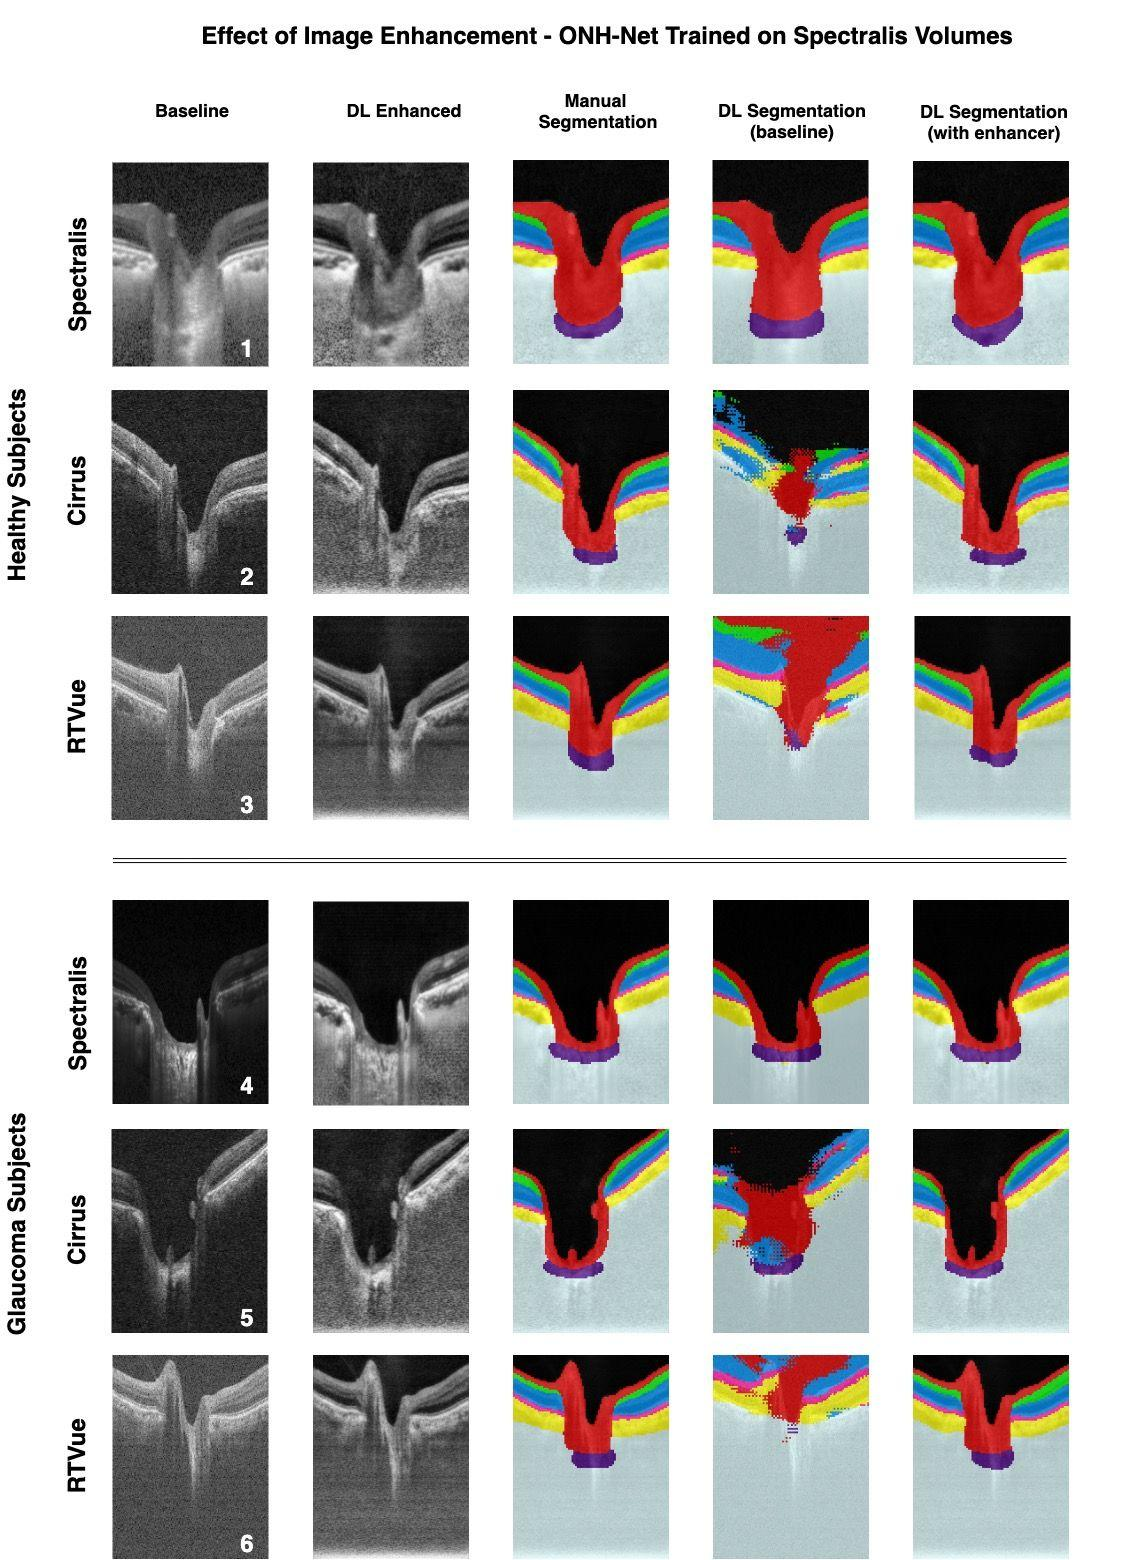In the context of the provided image, why might deep learning-enhanced segmentation be preferred over manual segmentation? Deep learning-enhanced segmentation may be preferred over manual segmentation for several reasons. Firstly, manual segmentation, while accurate, is labor-intensive and time-consuming, which limits its practicality in high-volume clinical settings. In contrast, DL-enhanced segmentation can be automated, greatly reducing analysis time. Secondly, DL algorithms can maintain consistency across numerous images, eliminating the variability introduced by different human operators. Lastly, advanced DL algorithms, once trained on enhanced images, may reveal details and patterns not readily apparent to human operators, potentially leading to new insights into retinal diseases. 